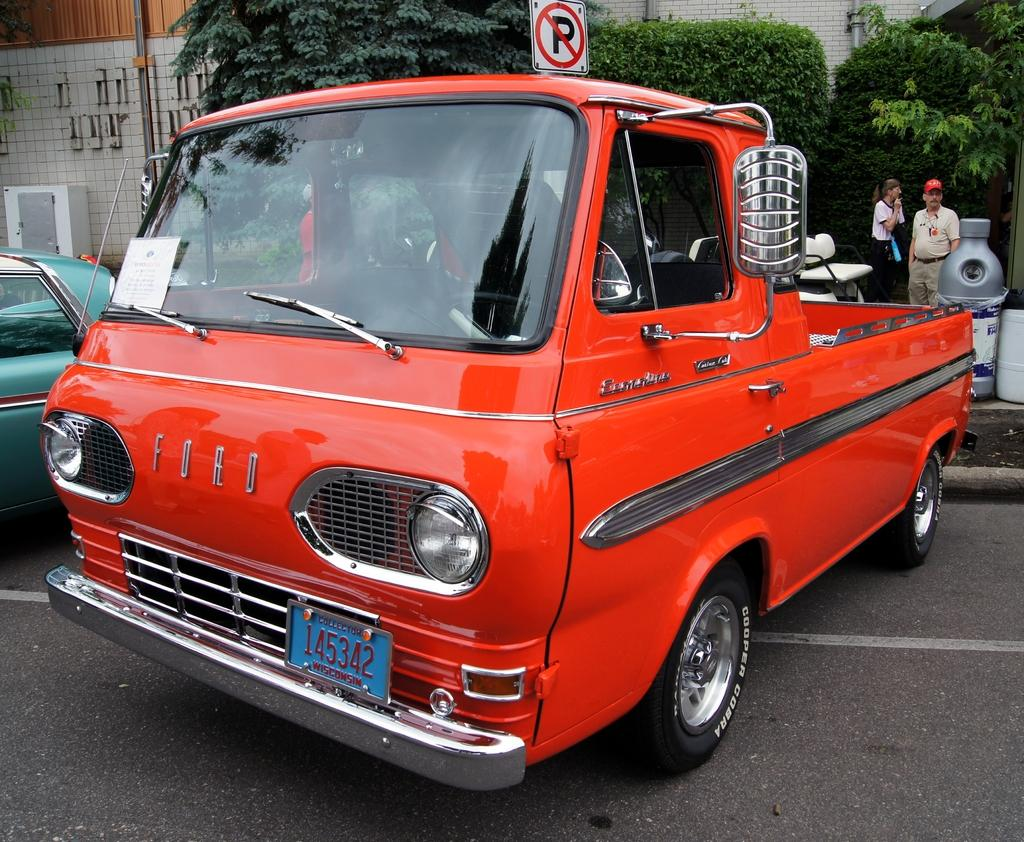<image>
Provide a brief description of the given image. The old style pick up truck shown in red is made by Ford. 